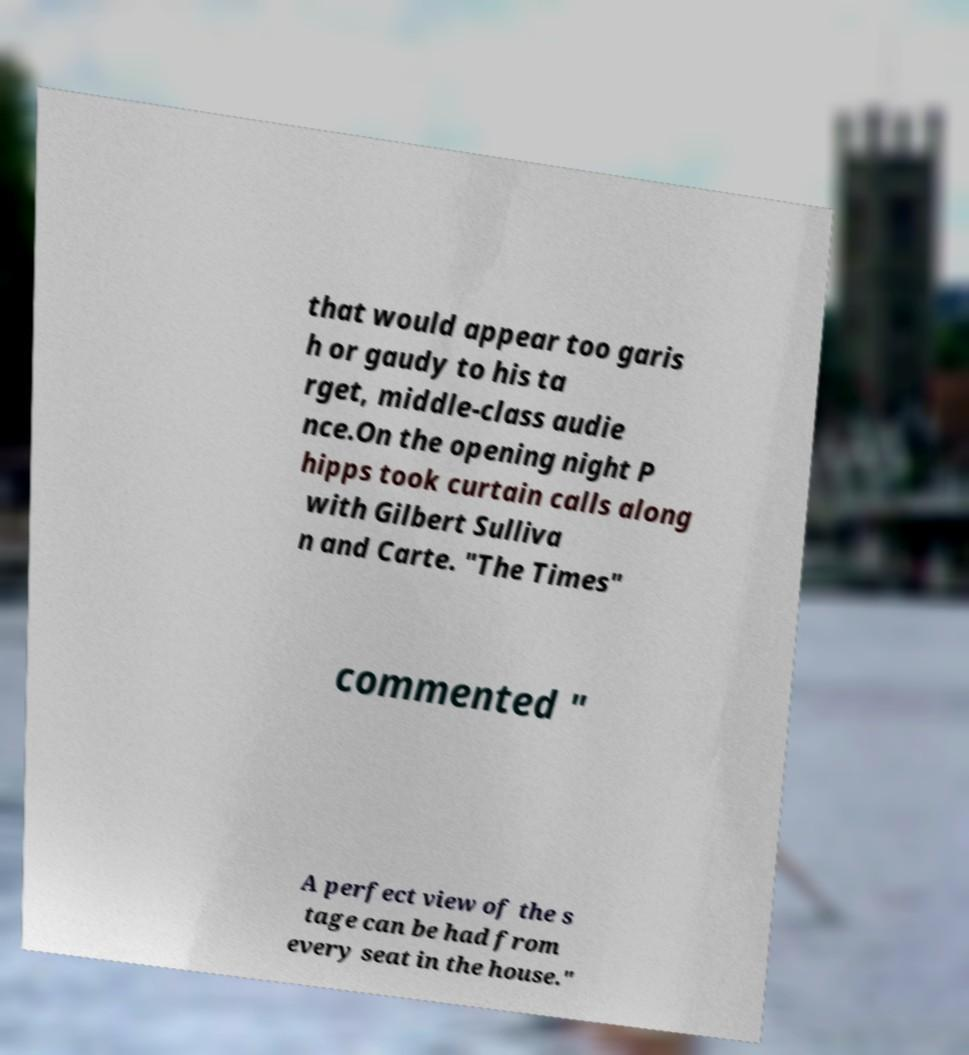Could you assist in decoding the text presented in this image and type it out clearly? that would appear too garis h or gaudy to his ta rget, middle-class audie nce.On the opening night P hipps took curtain calls along with Gilbert Sulliva n and Carte. "The Times" commented " A perfect view of the s tage can be had from every seat in the house." 